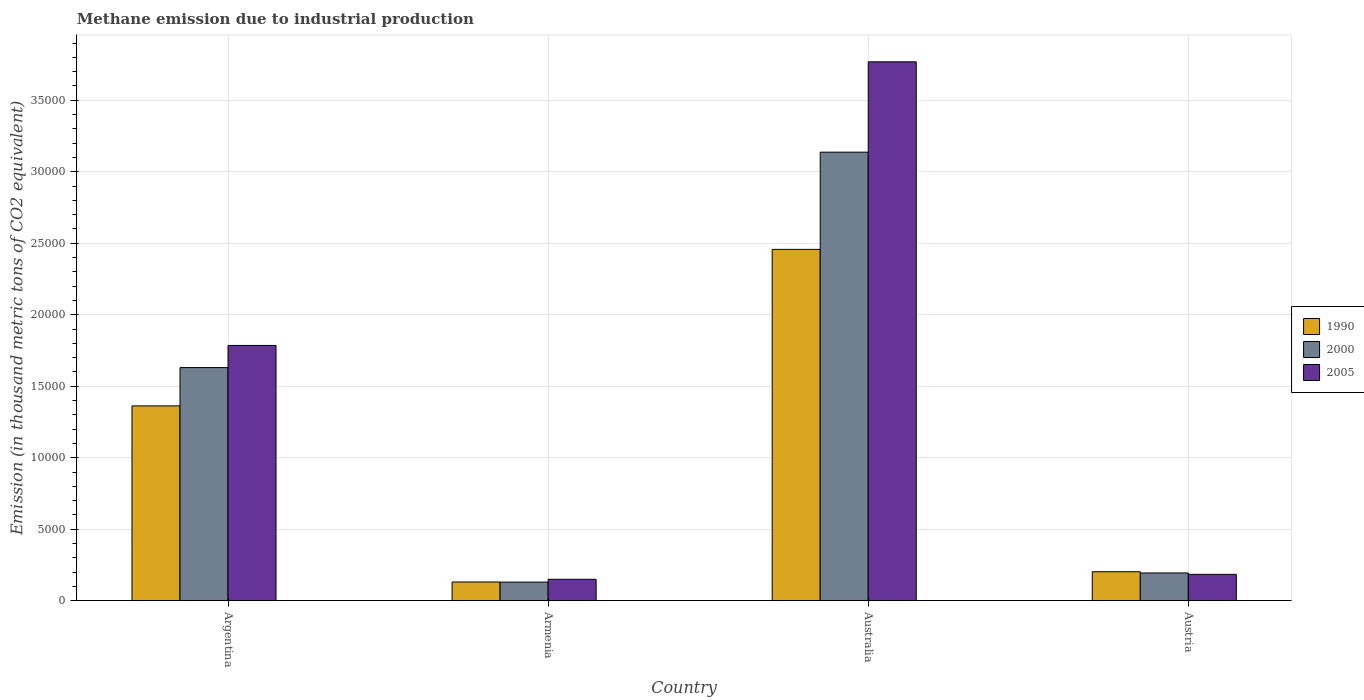How many different coloured bars are there?
Your response must be concise. 3. How many groups of bars are there?
Offer a terse response. 4. How many bars are there on the 3rd tick from the left?
Provide a succinct answer. 3. In how many cases, is the number of bars for a given country not equal to the number of legend labels?
Offer a very short reply. 0. What is the amount of methane emitted in 1990 in Australia?
Provide a succinct answer. 2.46e+04. Across all countries, what is the maximum amount of methane emitted in 1990?
Offer a terse response. 2.46e+04. Across all countries, what is the minimum amount of methane emitted in 1990?
Make the answer very short. 1313.2. In which country was the amount of methane emitted in 2005 minimum?
Provide a short and direct response. Armenia. What is the total amount of methane emitted in 2000 in the graph?
Your response must be concise. 5.09e+04. What is the difference between the amount of methane emitted in 2005 in Argentina and that in Austria?
Offer a very short reply. 1.60e+04. What is the difference between the amount of methane emitted in 2000 in Austria and the amount of methane emitted in 1990 in Australia?
Your answer should be compact. -2.26e+04. What is the average amount of methane emitted in 2005 per country?
Ensure brevity in your answer.  1.47e+04. What is the difference between the amount of methane emitted of/in 2005 and amount of methane emitted of/in 1990 in Austria?
Your answer should be compact. -182.3. What is the ratio of the amount of methane emitted in 2000 in Armenia to that in Austria?
Ensure brevity in your answer.  0.67. Is the amount of methane emitted in 2005 in Argentina less than that in Armenia?
Your answer should be very brief. No. Is the difference between the amount of methane emitted in 2005 in Armenia and Austria greater than the difference between the amount of methane emitted in 1990 in Armenia and Austria?
Provide a succinct answer. Yes. What is the difference between the highest and the second highest amount of methane emitted in 2000?
Give a very brief answer. 2.94e+04. What is the difference between the highest and the lowest amount of methane emitted in 1990?
Provide a short and direct response. 2.33e+04. What does the 2nd bar from the left in Argentina represents?
Give a very brief answer. 2000. What does the 2nd bar from the right in Australia represents?
Your answer should be very brief. 2000. Are all the bars in the graph horizontal?
Give a very brief answer. No. What is the difference between two consecutive major ticks on the Y-axis?
Your answer should be compact. 5000. Does the graph contain any zero values?
Provide a succinct answer. No. How are the legend labels stacked?
Your answer should be very brief. Vertical. What is the title of the graph?
Make the answer very short. Methane emission due to industrial production. Does "1999" appear as one of the legend labels in the graph?
Your answer should be very brief. No. What is the label or title of the Y-axis?
Provide a succinct answer. Emission (in thousand metric tons of CO2 equivalent). What is the Emission (in thousand metric tons of CO2 equivalent) in 1990 in Argentina?
Make the answer very short. 1.36e+04. What is the Emission (in thousand metric tons of CO2 equivalent) in 2000 in Argentina?
Provide a succinct answer. 1.63e+04. What is the Emission (in thousand metric tons of CO2 equivalent) of 2005 in Argentina?
Make the answer very short. 1.79e+04. What is the Emission (in thousand metric tons of CO2 equivalent) of 1990 in Armenia?
Your answer should be compact. 1313.2. What is the Emission (in thousand metric tons of CO2 equivalent) of 2000 in Armenia?
Provide a succinct answer. 1306.1. What is the Emission (in thousand metric tons of CO2 equivalent) of 2005 in Armenia?
Give a very brief answer. 1502.5. What is the Emission (in thousand metric tons of CO2 equivalent) in 1990 in Australia?
Your answer should be compact. 2.46e+04. What is the Emission (in thousand metric tons of CO2 equivalent) of 2000 in Australia?
Provide a succinct answer. 3.14e+04. What is the Emission (in thousand metric tons of CO2 equivalent) of 2005 in Australia?
Give a very brief answer. 3.77e+04. What is the Emission (in thousand metric tons of CO2 equivalent) in 1990 in Austria?
Provide a succinct answer. 2030.6. What is the Emission (in thousand metric tons of CO2 equivalent) in 2000 in Austria?
Offer a terse response. 1944.7. What is the Emission (in thousand metric tons of CO2 equivalent) in 2005 in Austria?
Make the answer very short. 1848.3. Across all countries, what is the maximum Emission (in thousand metric tons of CO2 equivalent) in 1990?
Keep it short and to the point. 2.46e+04. Across all countries, what is the maximum Emission (in thousand metric tons of CO2 equivalent) of 2000?
Provide a succinct answer. 3.14e+04. Across all countries, what is the maximum Emission (in thousand metric tons of CO2 equivalent) in 2005?
Give a very brief answer. 3.77e+04. Across all countries, what is the minimum Emission (in thousand metric tons of CO2 equivalent) in 1990?
Offer a terse response. 1313.2. Across all countries, what is the minimum Emission (in thousand metric tons of CO2 equivalent) of 2000?
Ensure brevity in your answer.  1306.1. Across all countries, what is the minimum Emission (in thousand metric tons of CO2 equivalent) in 2005?
Your answer should be compact. 1502.5. What is the total Emission (in thousand metric tons of CO2 equivalent) of 1990 in the graph?
Provide a succinct answer. 4.15e+04. What is the total Emission (in thousand metric tons of CO2 equivalent) in 2000 in the graph?
Your response must be concise. 5.09e+04. What is the total Emission (in thousand metric tons of CO2 equivalent) of 2005 in the graph?
Your answer should be compact. 5.89e+04. What is the difference between the Emission (in thousand metric tons of CO2 equivalent) in 1990 in Argentina and that in Armenia?
Offer a terse response. 1.23e+04. What is the difference between the Emission (in thousand metric tons of CO2 equivalent) in 2000 in Argentina and that in Armenia?
Provide a succinct answer. 1.50e+04. What is the difference between the Emission (in thousand metric tons of CO2 equivalent) in 2005 in Argentina and that in Armenia?
Make the answer very short. 1.64e+04. What is the difference between the Emission (in thousand metric tons of CO2 equivalent) in 1990 in Argentina and that in Australia?
Provide a short and direct response. -1.09e+04. What is the difference between the Emission (in thousand metric tons of CO2 equivalent) of 2000 in Argentina and that in Australia?
Your answer should be very brief. -1.51e+04. What is the difference between the Emission (in thousand metric tons of CO2 equivalent) in 2005 in Argentina and that in Australia?
Ensure brevity in your answer.  -1.98e+04. What is the difference between the Emission (in thousand metric tons of CO2 equivalent) in 1990 in Argentina and that in Austria?
Offer a very short reply. 1.16e+04. What is the difference between the Emission (in thousand metric tons of CO2 equivalent) of 2000 in Argentina and that in Austria?
Provide a succinct answer. 1.44e+04. What is the difference between the Emission (in thousand metric tons of CO2 equivalent) of 2005 in Argentina and that in Austria?
Your answer should be very brief. 1.60e+04. What is the difference between the Emission (in thousand metric tons of CO2 equivalent) of 1990 in Armenia and that in Australia?
Keep it short and to the point. -2.33e+04. What is the difference between the Emission (in thousand metric tons of CO2 equivalent) in 2000 in Armenia and that in Australia?
Provide a short and direct response. -3.01e+04. What is the difference between the Emission (in thousand metric tons of CO2 equivalent) in 2005 in Armenia and that in Australia?
Keep it short and to the point. -3.62e+04. What is the difference between the Emission (in thousand metric tons of CO2 equivalent) in 1990 in Armenia and that in Austria?
Give a very brief answer. -717.4. What is the difference between the Emission (in thousand metric tons of CO2 equivalent) of 2000 in Armenia and that in Austria?
Your response must be concise. -638.6. What is the difference between the Emission (in thousand metric tons of CO2 equivalent) in 2005 in Armenia and that in Austria?
Your response must be concise. -345.8. What is the difference between the Emission (in thousand metric tons of CO2 equivalent) in 1990 in Australia and that in Austria?
Your answer should be compact. 2.25e+04. What is the difference between the Emission (in thousand metric tons of CO2 equivalent) in 2000 in Australia and that in Austria?
Ensure brevity in your answer.  2.94e+04. What is the difference between the Emission (in thousand metric tons of CO2 equivalent) of 2005 in Australia and that in Austria?
Your answer should be compact. 3.58e+04. What is the difference between the Emission (in thousand metric tons of CO2 equivalent) of 1990 in Argentina and the Emission (in thousand metric tons of CO2 equivalent) of 2000 in Armenia?
Your response must be concise. 1.23e+04. What is the difference between the Emission (in thousand metric tons of CO2 equivalent) in 1990 in Argentina and the Emission (in thousand metric tons of CO2 equivalent) in 2005 in Armenia?
Ensure brevity in your answer.  1.21e+04. What is the difference between the Emission (in thousand metric tons of CO2 equivalent) of 2000 in Argentina and the Emission (in thousand metric tons of CO2 equivalent) of 2005 in Armenia?
Offer a very short reply. 1.48e+04. What is the difference between the Emission (in thousand metric tons of CO2 equivalent) in 1990 in Argentina and the Emission (in thousand metric tons of CO2 equivalent) in 2000 in Australia?
Provide a succinct answer. -1.77e+04. What is the difference between the Emission (in thousand metric tons of CO2 equivalent) in 1990 in Argentina and the Emission (in thousand metric tons of CO2 equivalent) in 2005 in Australia?
Give a very brief answer. -2.41e+04. What is the difference between the Emission (in thousand metric tons of CO2 equivalent) of 2000 in Argentina and the Emission (in thousand metric tons of CO2 equivalent) of 2005 in Australia?
Offer a very short reply. -2.14e+04. What is the difference between the Emission (in thousand metric tons of CO2 equivalent) of 1990 in Argentina and the Emission (in thousand metric tons of CO2 equivalent) of 2000 in Austria?
Offer a terse response. 1.17e+04. What is the difference between the Emission (in thousand metric tons of CO2 equivalent) in 1990 in Argentina and the Emission (in thousand metric tons of CO2 equivalent) in 2005 in Austria?
Your answer should be compact. 1.18e+04. What is the difference between the Emission (in thousand metric tons of CO2 equivalent) of 2000 in Argentina and the Emission (in thousand metric tons of CO2 equivalent) of 2005 in Austria?
Your answer should be compact. 1.45e+04. What is the difference between the Emission (in thousand metric tons of CO2 equivalent) of 1990 in Armenia and the Emission (in thousand metric tons of CO2 equivalent) of 2000 in Australia?
Provide a succinct answer. -3.01e+04. What is the difference between the Emission (in thousand metric tons of CO2 equivalent) of 1990 in Armenia and the Emission (in thousand metric tons of CO2 equivalent) of 2005 in Australia?
Provide a short and direct response. -3.64e+04. What is the difference between the Emission (in thousand metric tons of CO2 equivalent) in 2000 in Armenia and the Emission (in thousand metric tons of CO2 equivalent) in 2005 in Australia?
Provide a succinct answer. -3.64e+04. What is the difference between the Emission (in thousand metric tons of CO2 equivalent) of 1990 in Armenia and the Emission (in thousand metric tons of CO2 equivalent) of 2000 in Austria?
Provide a short and direct response. -631.5. What is the difference between the Emission (in thousand metric tons of CO2 equivalent) of 1990 in Armenia and the Emission (in thousand metric tons of CO2 equivalent) of 2005 in Austria?
Make the answer very short. -535.1. What is the difference between the Emission (in thousand metric tons of CO2 equivalent) of 2000 in Armenia and the Emission (in thousand metric tons of CO2 equivalent) of 2005 in Austria?
Ensure brevity in your answer.  -542.2. What is the difference between the Emission (in thousand metric tons of CO2 equivalent) in 1990 in Australia and the Emission (in thousand metric tons of CO2 equivalent) in 2000 in Austria?
Make the answer very short. 2.26e+04. What is the difference between the Emission (in thousand metric tons of CO2 equivalent) in 1990 in Australia and the Emission (in thousand metric tons of CO2 equivalent) in 2005 in Austria?
Keep it short and to the point. 2.27e+04. What is the difference between the Emission (in thousand metric tons of CO2 equivalent) in 2000 in Australia and the Emission (in thousand metric tons of CO2 equivalent) in 2005 in Austria?
Ensure brevity in your answer.  2.95e+04. What is the average Emission (in thousand metric tons of CO2 equivalent) of 1990 per country?
Give a very brief answer. 1.04e+04. What is the average Emission (in thousand metric tons of CO2 equivalent) of 2000 per country?
Offer a very short reply. 1.27e+04. What is the average Emission (in thousand metric tons of CO2 equivalent) in 2005 per country?
Offer a terse response. 1.47e+04. What is the difference between the Emission (in thousand metric tons of CO2 equivalent) of 1990 and Emission (in thousand metric tons of CO2 equivalent) of 2000 in Argentina?
Provide a short and direct response. -2677.8. What is the difference between the Emission (in thousand metric tons of CO2 equivalent) in 1990 and Emission (in thousand metric tons of CO2 equivalent) in 2005 in Argentina?
Provide a short and direct response. -4226.1. What is the difference between the Emission (in thousand metric tons of CO2 equivalent) of 2000 and Emission (in thousand metric tons of CO2 equivalent) of 2005 in Argentina?
Provide a short and direct response. -1548.3. What is the difference between the Emission (in thousand metric tons of CO2 equivalent) of 1990 and Emission (in thousand metric tons of CO2 equivalent) of 2005 in Armenia?
Provide a succinct answer. -189.3. What is the difference between the Emission (in thousand metric tons of CO2 equivalent) in 2000 and Emission (in thousand metric tons of CO2 equivalent) in 2005 in Armenia?
Make the answer very short. -196.4. What is the difference between the Emission (in thousand metric tons of CO2 equivalent) of 1990 and Emission (in thousand metric tons of CO2 equivalent) of 2000 in Australia?
Give a very brief answer. -6797.8. What is the difference between the Emission (in thousand metric tons of CO2 equivalent) of 1990 and Emission (in thousand metric tons of CO2 equivalent) of 2005 in Australia?
Offer a terse response. -1.31e+04. What is the difference between the Emission (in thousand metric tons of CO2 equivalent) of 2000 and Emission (in thousand metric tons of CO2 equivalent) of 2005 in Australia?
Offer a terse response. -6316.4. What is the difference between the Emission (in thousand metric tons of CO2 equivalent) in 1990 and Emission (in thousand metric tons of CO2 equivalent) in 2000 in Austria?
Offer a terse response. 85.9. What is the difference between the Emission (in thousand metric tons of CO2 equivalent) of 1990 and Emission (in thousand metric tons of CO2 equivalent) of 2005 in Austria?
Your answer should be compact. 182.3. What is the difference between the Emission (in thousand metric tons of CO2 equivalent) of 2000 and Emission (in thousand metric tons of CO2 equivalent) of 2005 in Austria?
Make the answer very short. 96.4. What is the ratio of the Emission (in thousand metric tons of CO2 equivalent) of 1990 in Argentina to that in Armenia?
Give a very brief answer. 10.38. What is the ratio of the Emission (in thousand metric tons of CO2 equivalent) in 2000 in Argentina to that in Armenia?
Your response must be concise. 12.48. What is the ratio of the Emission (in thousand metric tons of CO2 equivalent) of 2005 in Argentina to that in Armenia?
Your answer should be compact. 11.88. What is the ratio of the Emission (in thousand metric tons of CO2 equivalent) in 1990 in Argentina to that in Australia?
Your answer should be very brief. 0.55. What is the ratio of the Emission (in thousand metric tons of CO2 equivalent) in 2000 in Argentina to that in Australia?
Your response must be concise. 0.52. What is the ratio of the Emission (in thousand metric tons of CO2 equivalent) of 2005 in Argentina to that in Australia?
Give a very brief answer. 0.47. What is the ratio of the Emission (in thousand metric tons of CO2 equivalent) in 1990 in Argentina to that in Austria?
Give a very brief answer. 6.71. What is the ratio of the Emission (in thousand metric tons of CO2 equivalent) of 2000 in Argentina to that in Austria?
Give a very brief answer. 8.38. What is the ratio of the Emission (in thousand metric tons of CO2 equivalent) in 2005 in Argentina to that in Austria?
Give a very brief answer. 9.66. What is the ratio of the Emission (in thousand metric tons of CO2 equivalent) in 1990 in Armenia to that in Australia?
Keep it short and to the point. 0.05. What is the ratio of the Emission (in thousand metric tons of CO2 equivalent) in 2000 in Armenia to that in Australia?
Provide a short and direct response. 0.04. What is the ratio of the Emission (in thousand metric tons of CO2 equivalent) in 2005 in Armenia to that in Australia?
Offer a very short reply. 0.04. What is the ratio of the Emission (in thousand metric tons of CO2 equivalent) in 1990 in Armenia to that in Austria?
Make the answer very short. 0.65. What is the ratio of the Emission (in thousand metric tons of CO2 equivalent) of 2000 in Armenia to that in Austria?
Provide a short and direct response. 0.67. What is the ratio of the Emission (in thousand metric tons of CO2 equivalent) in 2005 in Armenia to that in Austria?
Your answer should be compact. 0.81. What is the ratio of the Emission (in thousand metric tons of CO2 equivalent) in 2000 in Australia to that in Austria?
Provide a succinct answer. 16.13. What is the ratio of the Emission (in thousand metric tons of CO2 equivalent) of 2005 in Australia to that in Austria?
Give a very brief answer. 20.39. What is the difference between the highest and the second highest Emission (in thousand metric tons of CO2 equivalent) of 1990?
Offer a very short reply. 1.09e+04. What is the difference between the highest and the second highest Emission (in thousand metric tons of CO2 equivalent) in 2000?
Provide a short and direct response. 1.51e+04. What is the difference between the highest and the second highest Emission (in thousand metric tons of CO2 equivalent) of 2005?
Keep it short and to the point. 1.98e+04. What is the difference between the highest and the lowest Emission (in thousand metric tons of CO2 equivalent) of 1990?
Offer a very short reply. 2.33e+04. What is the difference between the highest and the lowest Emission (in thousand metric tons of CO2 equivalent) in 2000?
Give a very brief answer. 3.01e+04. What is the difference between the highest and the lowest Emission (in thousand metric tons of CO2 equivalent) of 2005?
Provide a succinct answer. 3.62e+04. 